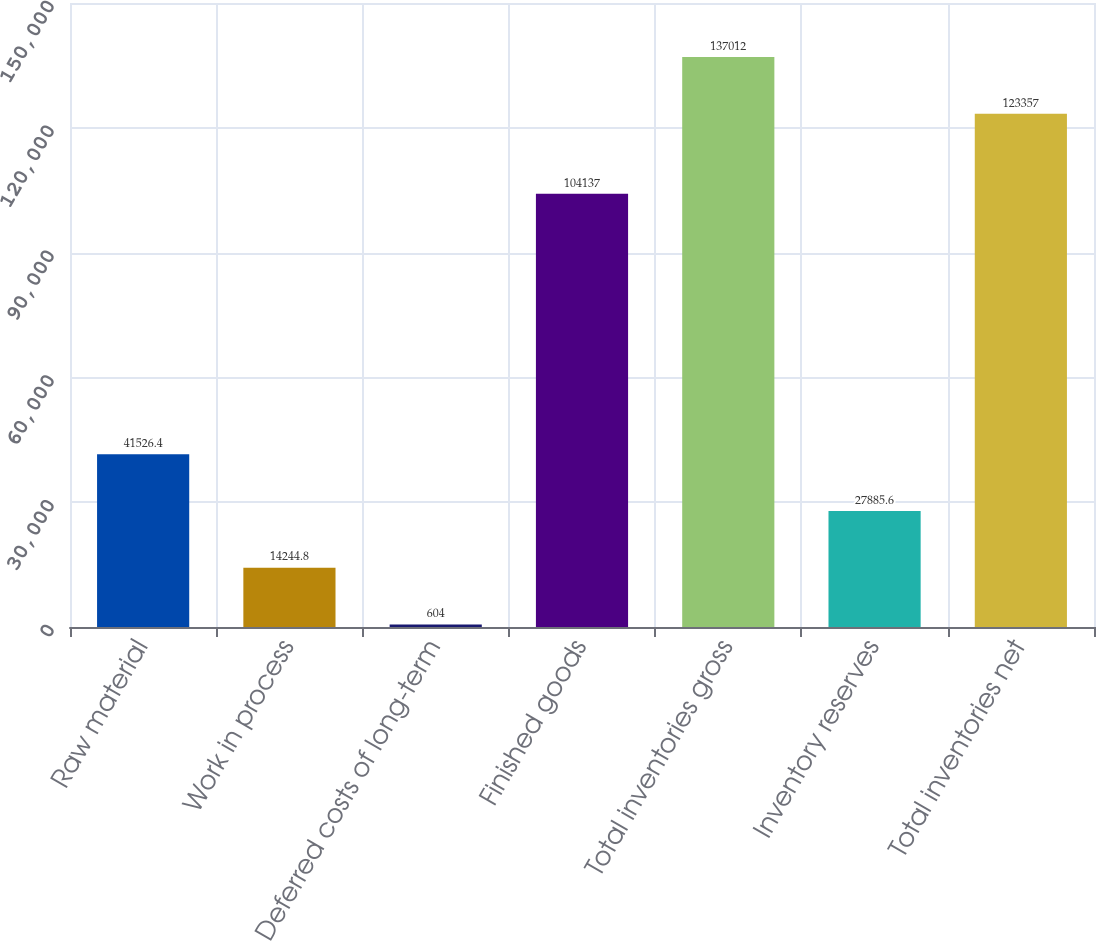<chart> <loc_0><loc_0><loc_500><loc_500><bar_chart><fcel>Raw material<fcel>Work in process<fcel>Deferred costs of long-term<fcel>Finished goods<fcel>Total inventories gross<fcel>Inventory reserves<fcel>Total inventories net<nl><fcel>41526.4<fcel>14244.8<fcel>604<fcel>104137<fcel>137012<fcel>27885.6<fcel>123357<nl></chart> 